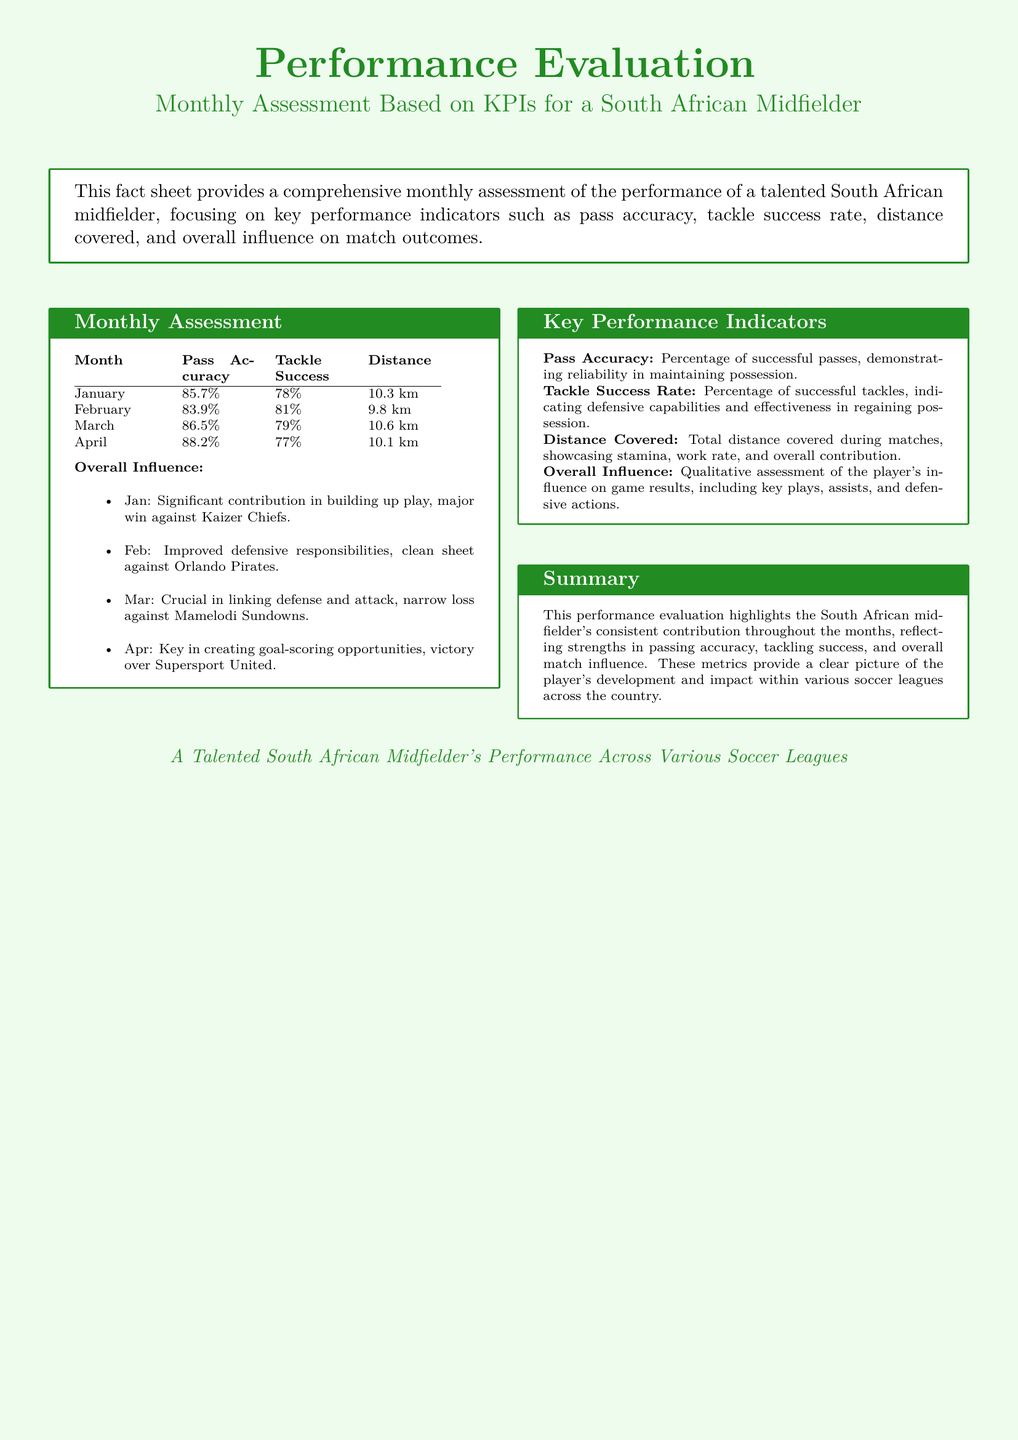What was the pass accuracy in January? The pass accuracy in January is listed in the monthly assessment section of the document.
Answer: 85.7% What is the tackle success rate in February? The tackle success rate for February can be found in the monthly assessment table.
Answer: 81% How far did the player cover in March? The distance covered in March is specified in the table under the distance column.
Answer: 10.6 km What was the overall influence for April? The overall influence for April is noted as a qualitative assessment in the corresponding section of the document.
Answer: Key in creating goal-scoring opportunities, victory over Supersport United Which month had the highest pass accuracy? This question requires comparing the pass accuracies from all months listed in the table.
Answer: April What does tackle success rate indicate? The definition of tackle success rate is explicitly provided in the key performance indicators section.
Answer: Indicating defensive capabilities and effectiveness in regaining possession What is the distance covered in January? The specific distance covered in January is mentioned in the monthly assessment part of the document.
Answer: 10.3 km What is the document type? The general categorization of the document can be inferred from its title.
Answer: Fact sheet 